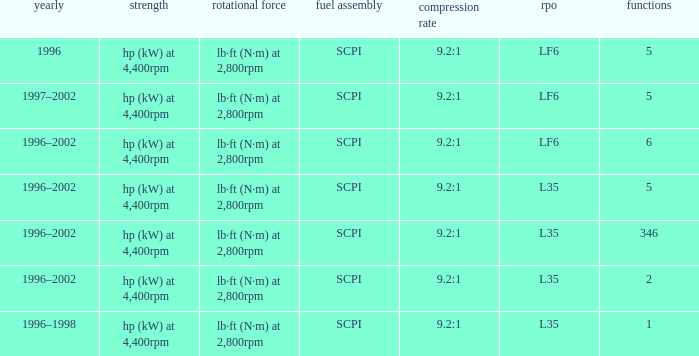What are the torque characteristics of the model made in 1996? Lb·ft (n·m) at 2,800rpm. 